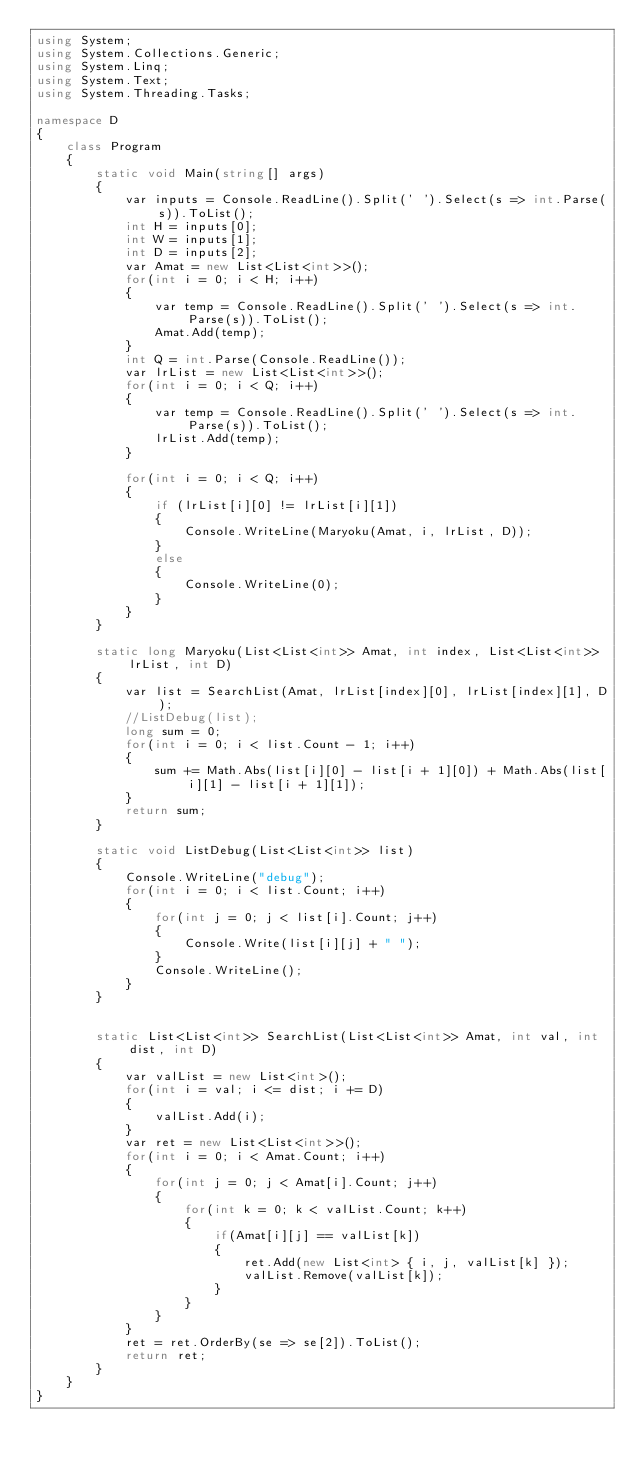<code> <loc_0><loc_0><loc_500><loc_500><_C#_>using System;
using System.Collections.Generic;
using System.Linq;
using System.Text;
using System.Threading.Tasks;

namespace D
{
    class Program
    {
        static void Main(string[] args)
        {
            var inputs = Console.ReadLine().Split(' ').Select(s => int.Parse(s)).ToList();
            int H = inputs[0];
            int W = inputs[1];
            int D = inputs[2];
            var Amat = new List<List<int>>();
            for(int i = 0; i < H; i++)
            {
                var temp = Console.ReadLine().Split(' ').Select(s => int.Parse(s)).ToList();
                Amat.Add(temp);
            }
            int Q = int.Parse(Console.ReadLine());
            var lrList = new List<List<int>>();
            for(int i = 0; i < Q; i++)
            {
                var temp = Console.ReadLine().Split(' ').Select(s => int.Parse(s)).ToList();
                lrList.Add(temp);
            }
            
            for(int i = 0; i < Q; i++)
            {
                if (lrList[i][0] != lrList[i][1])
                {
                    Console.WriteLine(Maryoku(Amat, i, lrList, D));
                }
                else
                {
                    Console.WriteLine(0);
                }
            }
        }

        static long Maryoku(List<List<int>> Amat, int index, List<List<int>> lrList, int D)
        {
            var list = SearchList(Amat, lrList[index][0], lrList[index][1], D);
            //ListDebug(list);
            long sum = 0;
            for(int i = 0; i < list.Count - 1; i++)
            {
                sum += Math.Abs(list[i][0] - list[i + 1][0]) + Math.Abs(list[i][1] - list[i + 1][1]);
            }
            return sum;
        }

        static void ListDebug(List<List<int>> list)
        {
            Console.WriteLine("debug");
            for(int i = 0; i < list.Count; i++)
            {
                for(int j = 0; j < list[i].Count; j++)
                {
                    Console.Write(list[i][j] + " ");
                }
                Console.WriteLine();
            }
        }


        static List<List<int>> SearchList(List<List<int>> Amat, int val, int dist, int D)
        {
            var valList = new List<int>();
            for(int i = val; i <= dist; i += D)
            {
                valList.Add(i);
            }
            var ret = new List<List<int>>();
            for(int i = 0; i < Amat.Count; i++)
            {
                for(int j = 0; j < Amat[i].Count; j++)
                {
                    for(int k = 0; k < valList.Count; k++)
                    {
                        if(Amat[i][j] == valList[k])
                        {
                            ret.Add(new List<int> { i, j, valList[k] });
                            valList.Remove(valList[k]);
                        }
                    }
                }
            }
            ret = ret.OrderBy(se => se[2]).ToList();
            return ret;
        }
    }
}</code> 